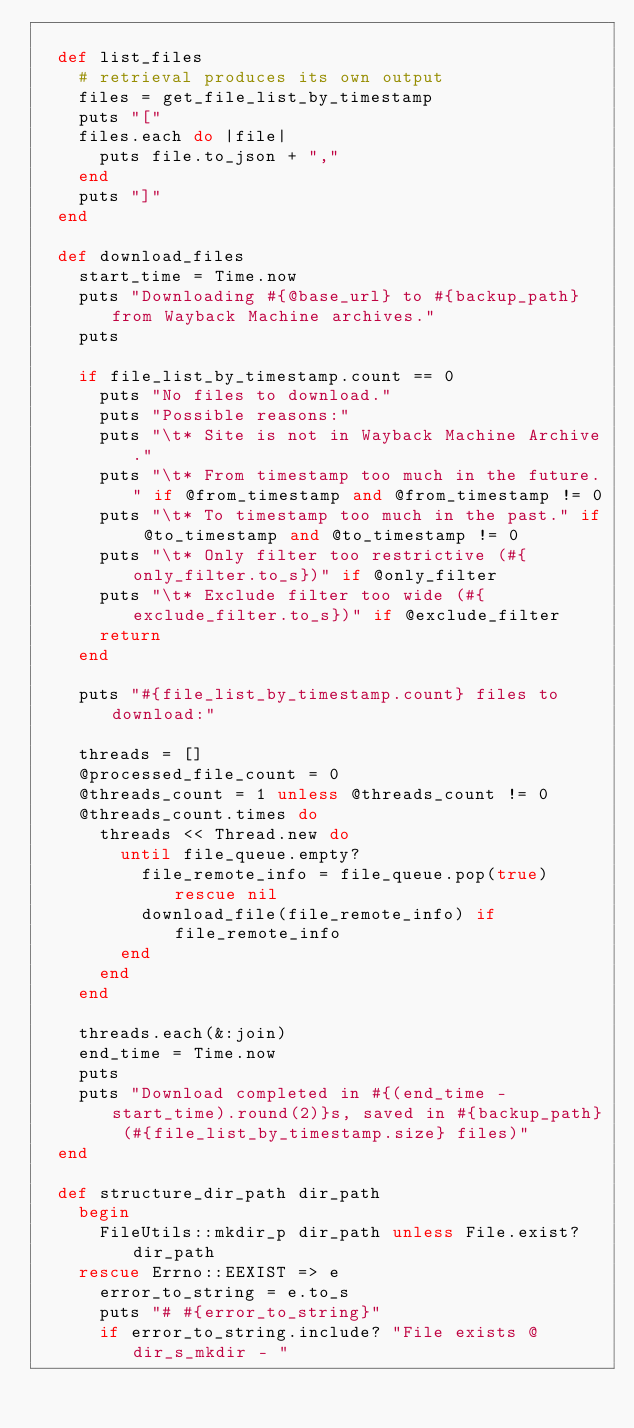<code> <loc_0><loc_0><loc_500><loc_500><_Ruby_>
  def list_files
    # retrieval produces its own output
    files = get_file_list_by_timestamp
    puts "["
    files.each do |file|
      puts file.to_json + ","
    end
    puts "]"
  end

  def download_files
    start_time = Time.now
    puts "Downloading #{@base_url} to #{backup_path} from Wayback Machine archives."
    puts

    if file_list_by_timestamp.count == 0
      puts "No files to download."
      puts "Possible reasons:"
      puts "\t* Site is not in Wayback Machine Archive."
      puts "\t* From timestamp too much in the future." if @from_timestamp and @from_timestamp != 0
      puts "\t* To timestamp too much in the past." if @to_timestamp and @to_timestamp != 0
      puts "\t* Only filter too restrictive (#{only_filter.to_s})" if @only_filter
      puts "\t* Exclude filter too wide (#{exclude_filter.to_s})" if @exclude_filter
      return
    end
 
    puts "#{file_list_by_timestamp.count} files to download:"

    threads = []
    @processed_file_count = 0
    @threads_count = 1 unless @threads_count != 0
    @threads_count.times do
      threads << Thread.new do
        until file_queue.empty?
          file_remote_info = file_queue.pop(true) rescue nil
          download_file(file_remote_info) if file_remote_info
        end
      end
    end

    threads.each(&:join)
    end_time = Time.now
    puts
    puts "Download completed in #{(end_time - start_time).round(2)}s, saved in #{backup_path} (#{file_list_by_timestamp.size} files)"
  end

  def structure_dir_path dir_path
    begin
      FileUtils::mkdir_p dir_path unless File.exist? dir_path
    rescue Errno::EEXIST => e
      error_to_string = e.to_s
      puts "# #{error_to_string}"
      if error_to_string.include? "File exists @ dir_s_mkdir - "</code> 